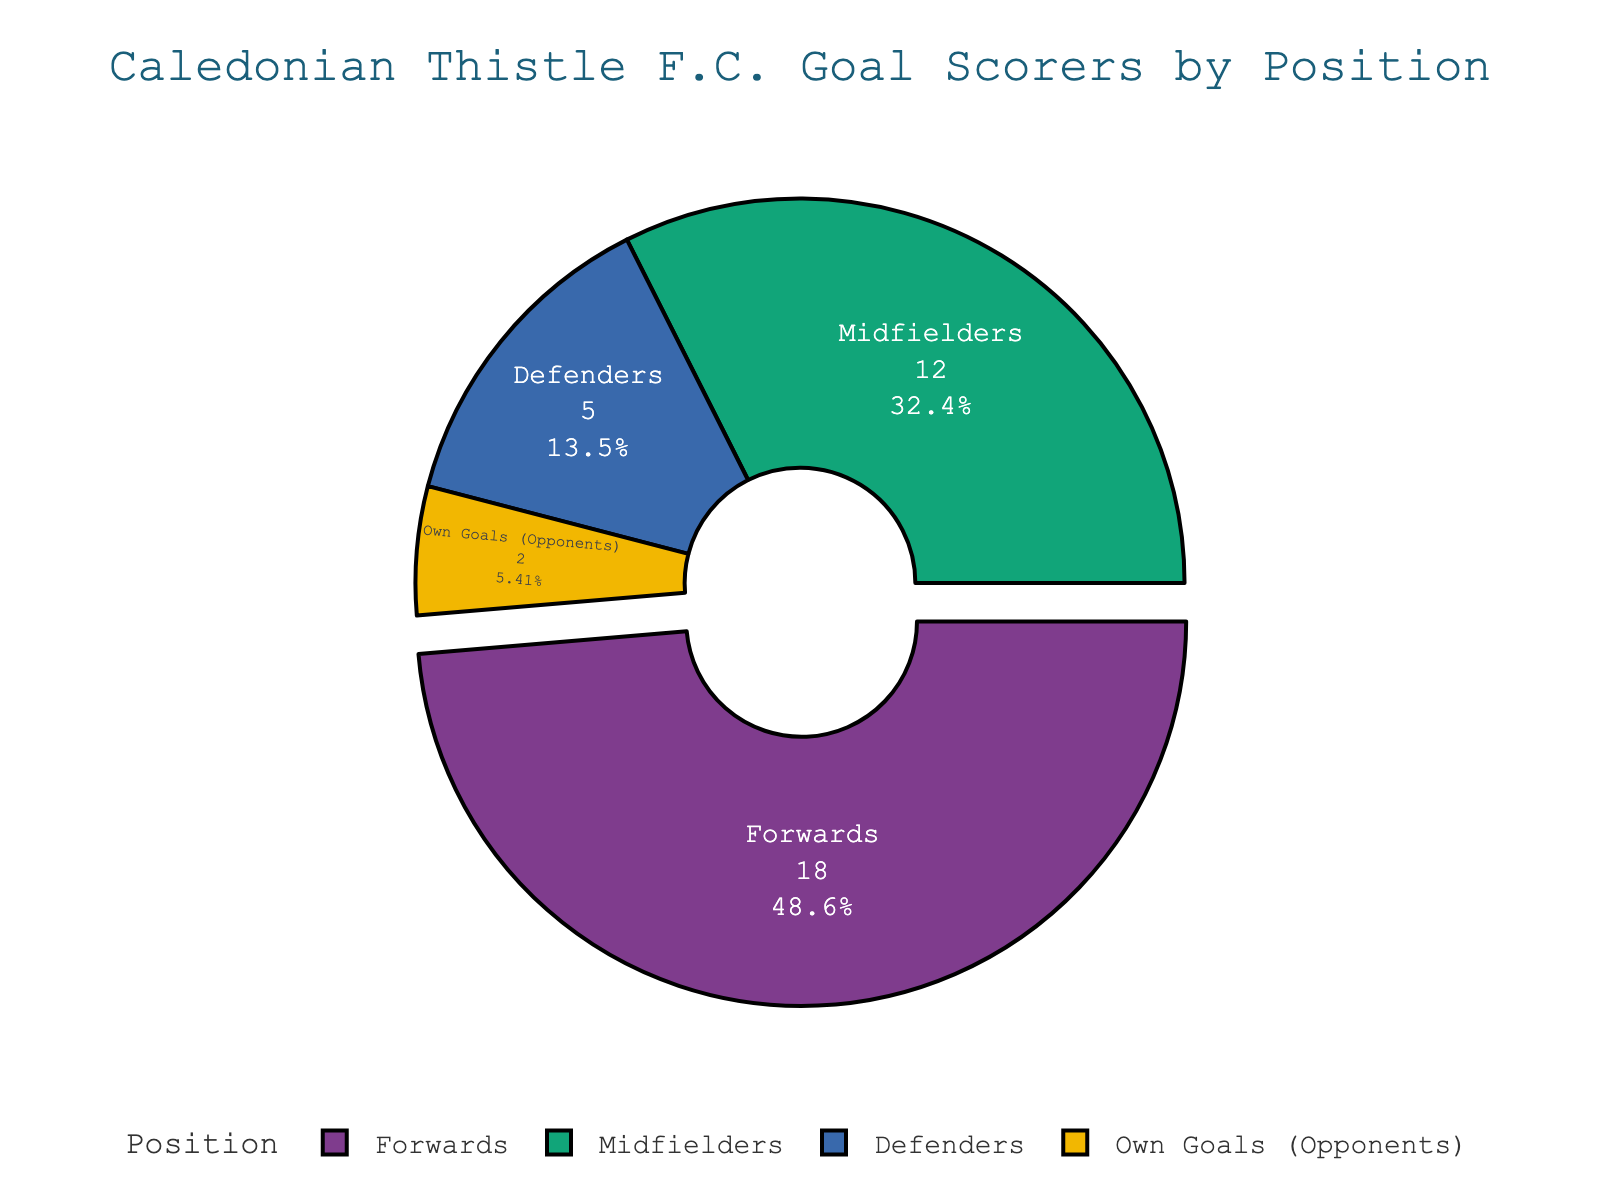What's the total number of goals scored by Caledonian Thistle F.C. this season? To find the total goals, sum the goals from all positions: Forwards (18), Midfielders (12), Defenders (5), and Own Goals (Opponents) (2). So, 18 + 12 + 5 + 2 = 37.
Answer: 37 Which position scored the most goals? Look at the pie chart and see which section is the largest. It's evident that Forwards scored the most goals.
Answer: Forwards How many more goals did the Forwards score than the Defenders? The number of goals by Forwards is 18, and by Defenders is 5. Subtract the Defenders' goals from the Forwards' goals: 18 - 5 = 13.
Answer: 13 Do Midfielders or Defenders have more goals, and by how many? Compare the goals scored by Midfielders (12) and Defenders (5). Subtract Defenders' goals from Midfielders' goals: 12 - 5 = 7.
Answer: Midfielders, by 7 What percentage of the total goals were own goals by opponents? Calculate the percentage by dividing the number of own goals by the total goals and multiplying by 100: (2 / 37) * 100 ≈ 5.41%.
Answer: Approximately 5.41% How much larger, in terms of percentage points, is the portion of goals scored by Forwards compared to Midfielders? Calculate the percentage of goals by Forwards and Midfielders. Forwards: (18 / 37) * 100 ≈ 48.65%. Midfielders: (12 / 37) * 100 ≈ 32.43%. Subtract Midfielders' percentage from Forwards': 48.65% - 32.43% ≈ 16.22%.
Answer: Approximately 16.22% What's the combined percentage of goals scored by Defenders and own goals by opponents? Calculate the individual percentages for both groups and sum them up. Defenders: (5 / 37) * 100 ≈ 13.51%. Own Goals: (2 / 37) * 100 ≈ 5.41%. So combined: 13.51% + 5.41% ≈ 18.92%.
Answer: Approximately 18.92% Which position contributes the lowest percentage of goals, and what is that percentage? From the pie chart, the smallest section corresponds to Own Goals (Opponents) with 2 goals. Calculate the percentage: (2 / 37) * 100 ≈ 5.41%.
Answer: Own Goals (Opponents), 5.41% If Defenders doubled their goals, what fraction of the total goals would they then have? If Defenders scored double their current goals, it would be 5 * 2 = 10 goals. The new total goals would be 37 - 5 + 10 = 42. So the fraction would be 10/42 = 5/21.
Answer: 5/21 